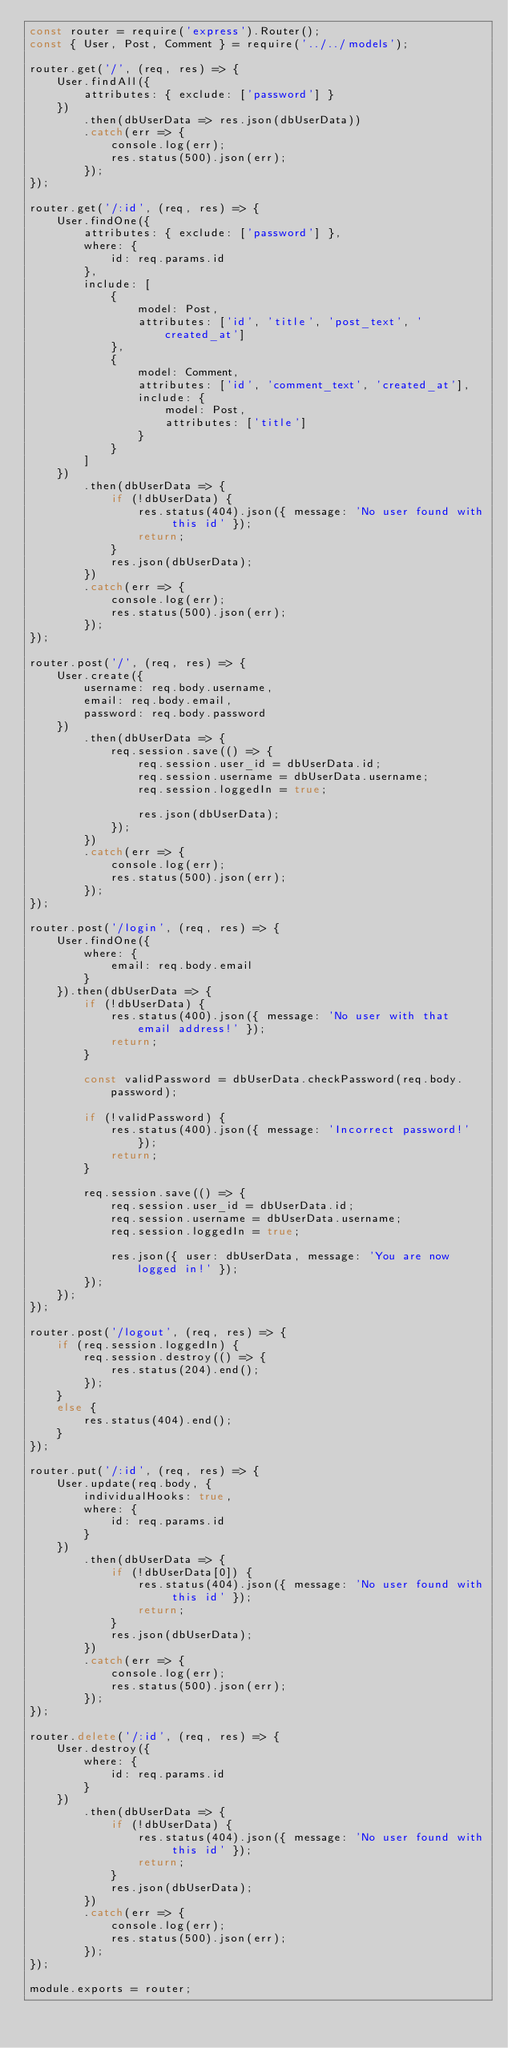Convert code to text. <code><loc_0><loc_0><loc_500><loc_500><_JavaScript_>const router = require('express').Router();
const { User, Post, Comment } = require('../../models');

router.get('/', (req, res) => {
    User.findAll({
        attributes: { exclude: ['password'] }
    })
        .then(dbUserData => res.json(dbUserData))
        .catch(err => {
            console.log(err);
            res.status(500).json(err);
        });
});

router.get('/:id', (req, res) => {
    User.findOne({
        attributes: { exclude: ['password'] },
        where: {
            id: req.params.id
        },
        include: [
            {
                model: Post,
                attributes: ['id', 'title', 'post_text', 'created_at']
            },
            {
                model: Comment,
                attributes: ['id', 'comment_text', 'created_at'],
                include: {
                    model: Post,
                    attributes: ['title']
                }
            }
        ]
    })
        .then(dbUserData => {
            if (!dbUserData) {
                res.status(404).json({ message: 'No user found with this id' });
                return;
            }
            res.json(dbUserData);
        })
        .catch(err => {
            console.log(err);
            res.status(500).json(err);
        });
});

router.post('/', (req, res) => {
    User.create({
        username: req.body.username,
        email: req.body.email,
        password: req.body.password
    })
        .then(dbUserData => {
            req.session.save(() => {
                req.session.user_id = dbUserData.id;
                req.session.username = dbUserData.username;
                req.session.loggedIn = true;

                res.json(dbUserData);
            });
        })
        .catch(err => {
            console.log(err);
            res.status(500).json(err);
        });
});

router.post('/login', (req, res) => {
    User.findOne({
        where: {
            email: req.body.email
        }
    }).then(dbUserData => {
        if (!dbUserData) {
            res.status(400).json({ message: 'No user with that email address!' });
            return;
        }

        const validPassword = dbUserData.checkPassword(req.body.password);

        if (!validPassword) {
            res.status(400).json({ message: 'Incorrect password!' });
            return;
        }

        req.session.save(() => {
            req.session.user_id = dbUserData.id;
            req.session.username = dbUserData.username;
            req.session.loggedIn = true;

            res.json({ user: dbUserData, message: 'You are now logged in!' });
        });
    });
});

router.post('/logout', (req, res) => {
    if (req.session.loggedIn) {
        req.session.destroy(() => {
            res.status(204).end();
        });
    }
    else {
        res.status(404).end();
    }
});

router.put('/:id', (req, res) => {
    User.update(req.body, {
        individualHooks: true,
        where: {
            id: req.params.id
        }
    })
        .then(dbUserData => {
            if (!dbUserData[0]) {
                res.status(404).json({ message: 'No user found with this id' });
                return;
            }
            res.json(dbUserData);
        })
        .catch(err => {
            console.log(err);
            res.status(500).json(err);
        });
});

router.delete('/:id', (req, res) => {
    User.destroy({
        where: {
            id: req.params.id
        }
    })
        .then(dbUserData => {
            if (!dbUserData) {
                res.status(404).json({ message: 'No user found with this id' });
                return;
            }
            res.json(dbUserData);
        })
        .catch(err => {
            console.log(err);
            res.status(500).json(err);
        });
});

module.exports = router;</code> 